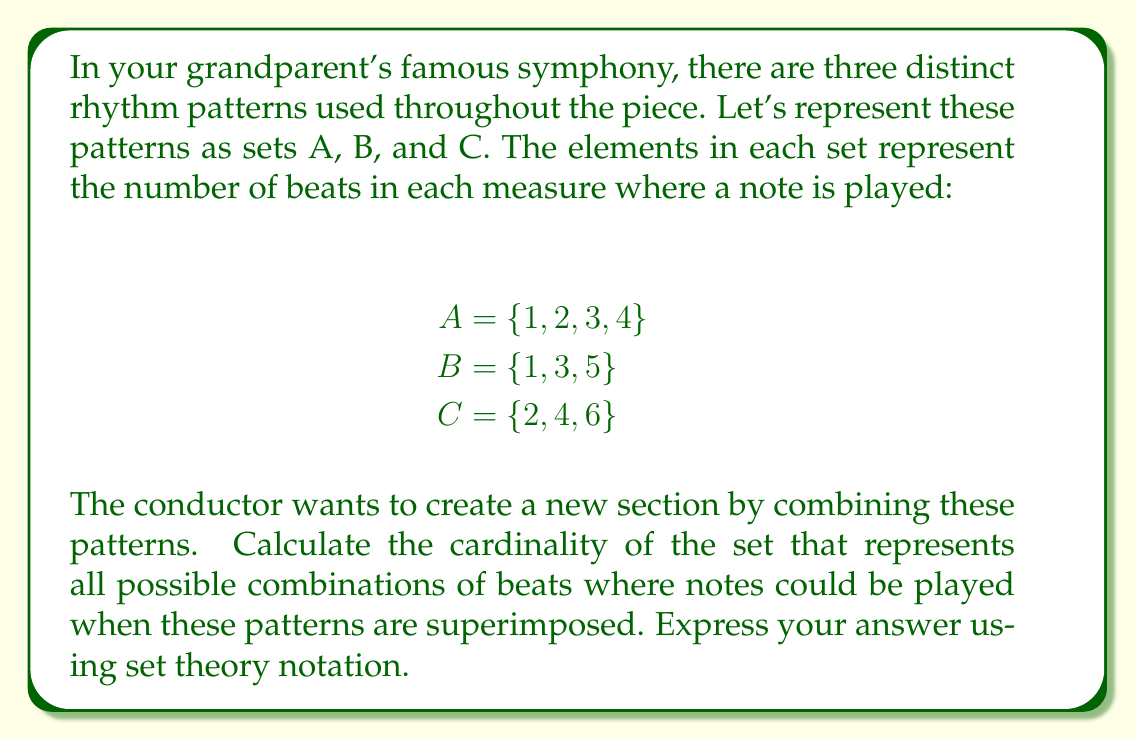Can you answer this question? To solve this problem, we need to find the union of all three sets and then calculate its cardinality. Let's approach this step-by-step:

1) First, we need to find the union of sets A, B, and C. In set theory notation, this is represented as $A \cup B \cup C$.

2) Let's list out all the unique elements in this union:
   $A \cup B \cup C = \{1, 2, 3, 4, 5, 6\}$

   Note that even though some numbers appear in multiple sets, they only appear once in the union.

3) The cardinality of a set is the number of elements in the set. In set theory notation, we represent the cardinality of a set X as $|X|$.

4) Therefore, the cardinality of the union of A, B, and C is:
   $|A \cup B \cup C| = 6$

5) The final answer should be expressed using set theory notation:
   $|A \cup B \cup C| = 6$

This result means that when all three rhythm patterns are superimposed, there are 6 distinct beat positions where notes could potentially be played in each measure.
Answer: $|A \cup B \cup C| = 6$ 